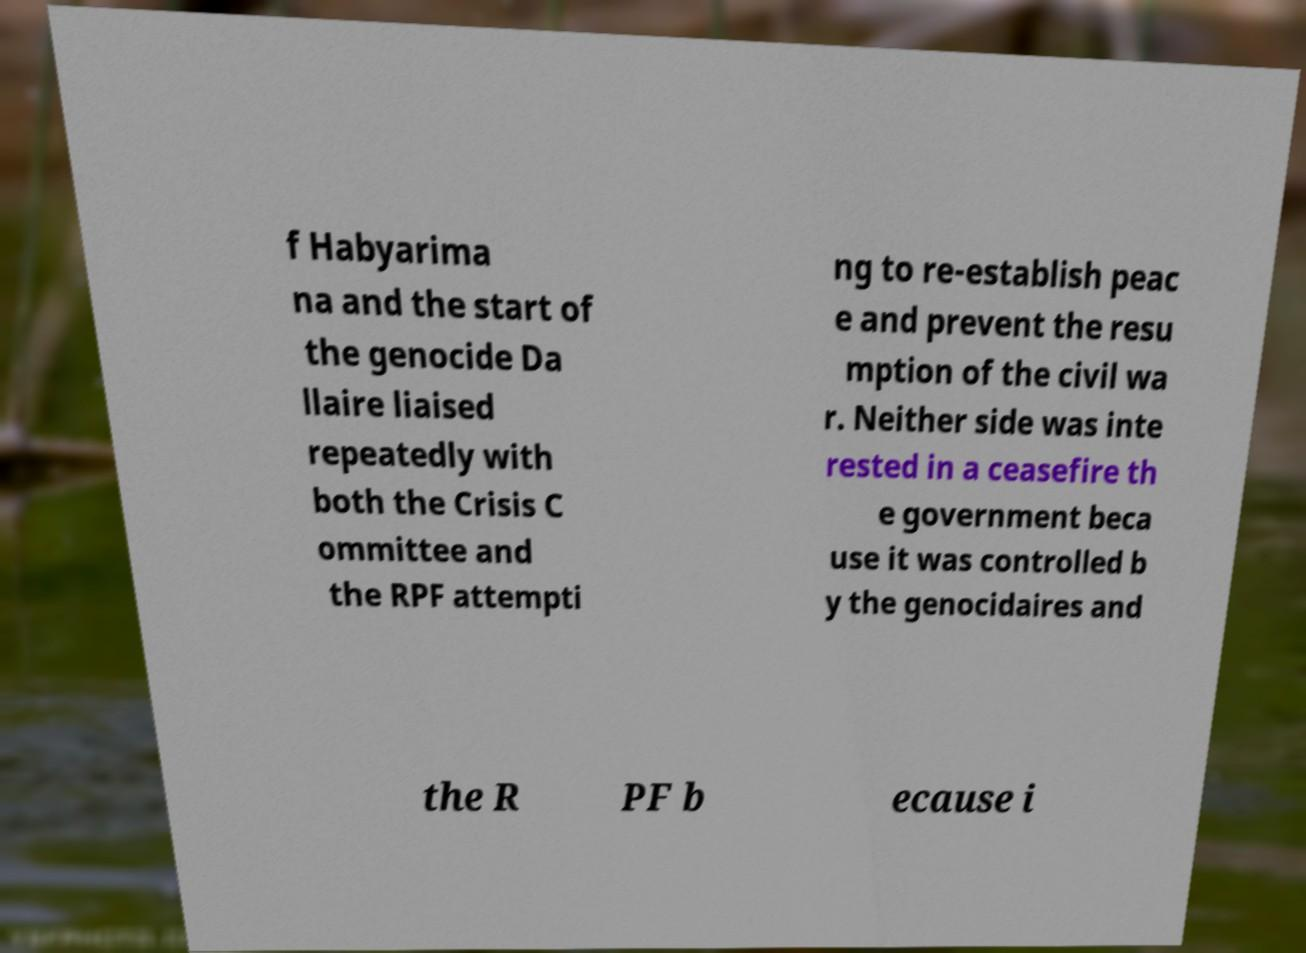Please read and relay the text visible in this image. What does it say? f Habyarima na and the start of the genocide Da llaire liaised repeatedly with both the Crisis C ommittee and the RPF attempti ng to re-establish peac e and prevent the resu mption of the civil wa r. Neither side was inte rested in a ceasefire th e government beca use it was controlled b y the genocidaires and the R PF b ecause i 